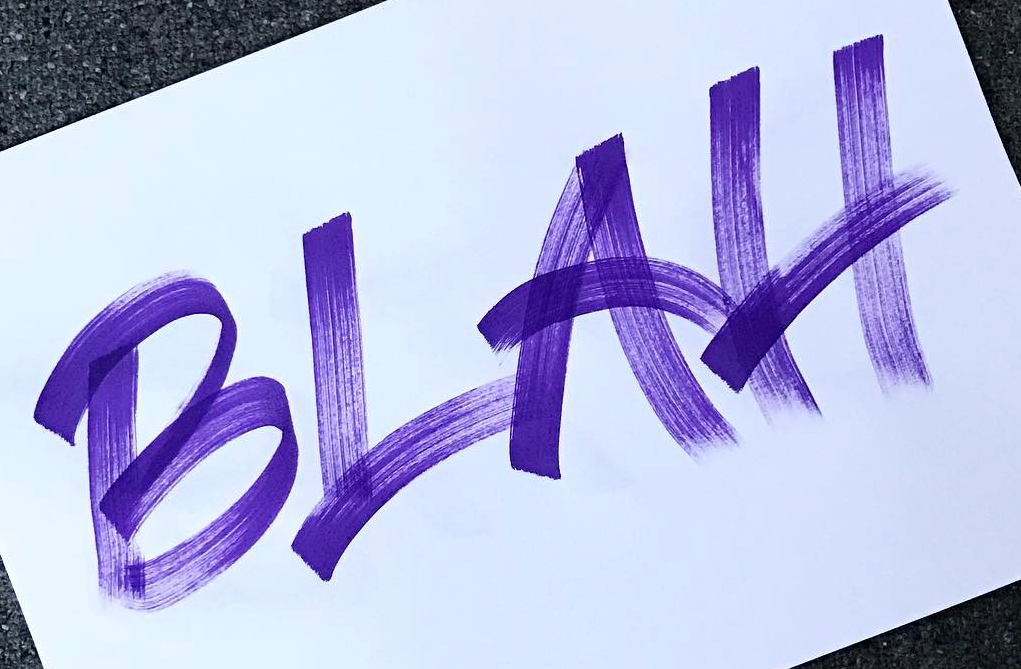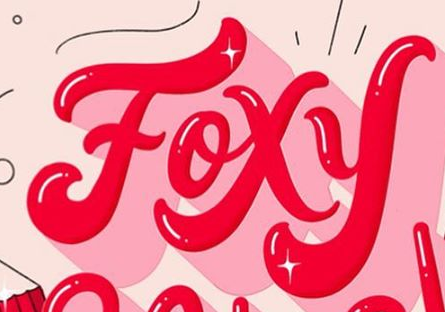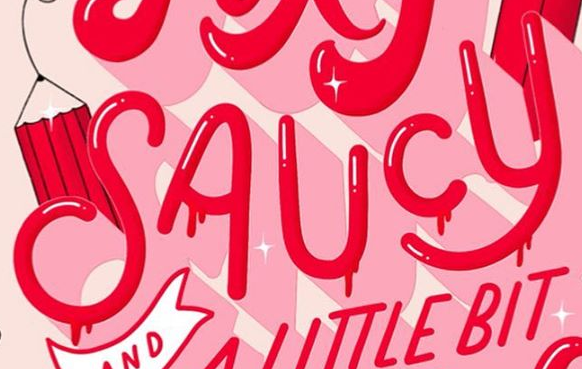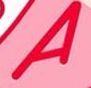What words can you see in these images in sequence, separated by a semicolon? BLAH; Foxy; SAUCY; A 